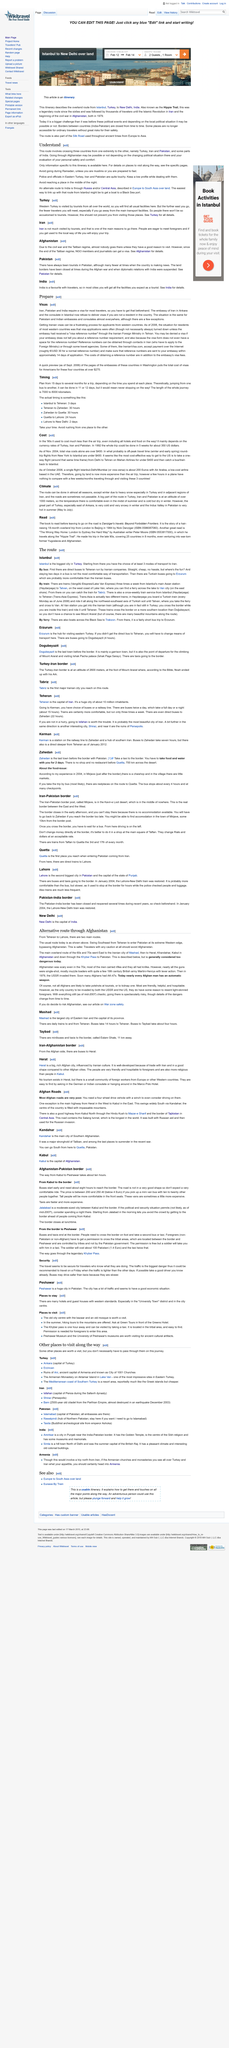Mention a couple of crucial points in this snapshot. The following route involves the countries of Turkey, Iran, and Pakistan: When should you avoid arriving at your destination at night? It is advisable to refrain from traveling unless one is a Muslim during the month of Ramadan. 